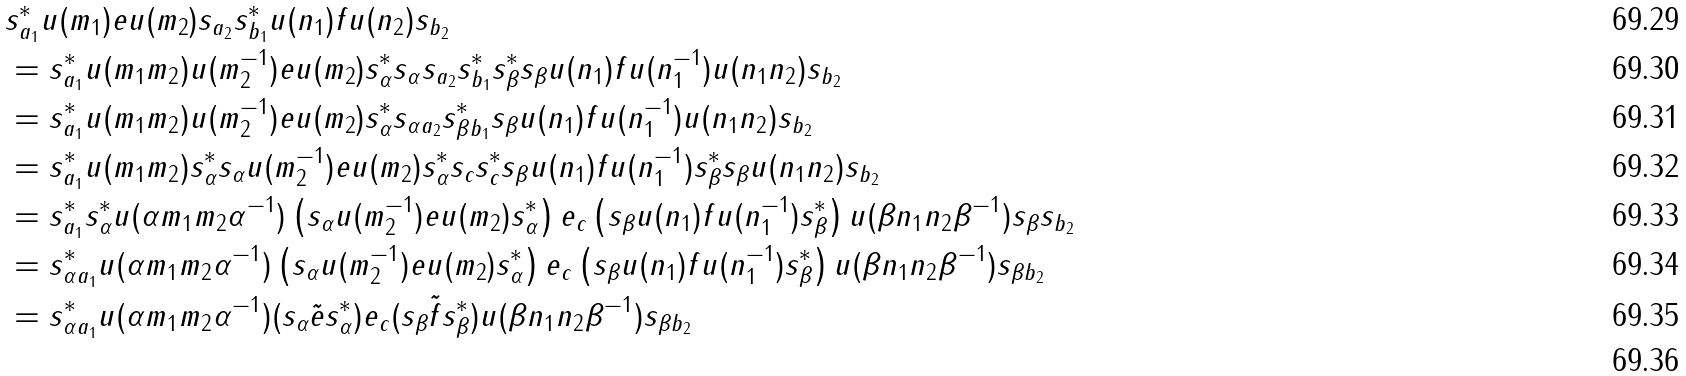<formula> <loc_0><loc_0><loc_500><loc_500>& s _ { a _ { 1 } } ^ { * } u ( m _ { 1 } ) e u ( m _ { 2 } ) s _ { a _ { 2 } } s _ { b _ { 1 } } ^ { * } u ( n _ { 1 } ) f u ( n _ { 2 } ) s _ { b _ { 2 } } \\ & = s _ { a _ { 1 } } ^ { * } u ( m _ { 1 } m _ { 2 } ) u ( m _ { 2 } ^ { - 1 } ) e u ( m _ { 2 } ) s _ { \alpha } ^ { * } s _ { \alpha } s _ { a _ { 2 } } s _ { b _ { 1 } } ^ { * } s _ { \beta } ^ { * } s _ { \beta } u ( n _ { 1 } ) f u ( n _ { 1 } ^ { - 1 } ) u ( n _ { 1 } n _ { 2 } ) s _ { b _ { 2 } } \\ & = s _ { a _ { 1 } } ^ { * } u ( m _ { 1 } m _ { 2 } ) u ( m _ { 2 } ^ { - 1 } ) e u ( m _ { 2 } ) s _ { \alpha } ^ { * } s _ { \alpha a _ { 2 } } s _ { \beta b _ { 1 } } ^ { * } s _ { \beta } u ( n _ { 1 } ) f u ( n _ { 1 } ^ { - 1 } ) u ( n _ { 1 } n _ { 2 } ) s _ { b _ { 2 } } \\ & = s _ { a _ { 1 } } ^ { * } u ( m _ { 1 } m _ { 2 } ) s _ { \alpha } ^ { * } s _ { \alpha } u ( m _ { 2 } ^ { - 1 } ) e u ( m _ { 2 } ) s _ { \alpha } ^ { * } s _ { c } s _ { c } ^ { * } s _ { \beta } u ( n _ { 1 } ) f u ( n _ { 1 } ^ { - 1 } ) s _ { \beta } ^ { * } s _ { \beta } u ( n _ { 1 } n _ { 2 } ) s _ { b _ { 2 } } \\ & = s _ { a _ { 1 } } ^ { * } s _ { \alpha } ^ { * } u ( \alpha m _ { 1 } m _ { 2 } \alpha ^ { - 1 } ) \left ( s _ { \alpha } u ( m _ { 2 } ^ { - 1 } ) e u ( m _ { 2 } ) s _ { \alpha } ^ { * } \right ) e _ { c } \left ( s _ { \beta } u ( n _ { 1 } ) f u ( n _ { 1 } ^ { - 1 } ) s _ { \beta } ^ { * } \right ) u ( \beta n _ { 1 } n _ { 2 } \beta ^ { - 1 } ) s _ { \beta } s _ { b _ { 2 } } \\ & = s _ { \alpha a _ { 1 } } ^ { * } u ( \alpha m _ { 1 } m _ { 2 } \alpha ^ { - 1 } ) \left ( s _ { \alpha } u ( m _ { 2 } ^ { - 1 } ) e u ( m _ { 2 } ) s _ { \alpha } ^ { * } \right ) e _ { c } \left ( s _ { \beta } u ( n _ { 1 } ) f u ( n _ { 1 } ^ { - 1 } ) s _ { \beta } ^ { * } \right ) u ( \beta n _ { 1 } n _ { 2 } \beta ^ { - 1 } ) s _ { \beta b _ { 2 } } \\ & = s _ { \alpha a _ { 1 } } ^ { * } u ( \alpha m _ { 1 } m _ { 2 } \alpha ^ { - 1 } ) ( s _ { \alpha } \tilde { e } s _ { \alpha } ^ { * } ) e _ { c } ( s _ { \beta } \tilde { f } s _ { \beta } ^ { * } ) u ( \beta n _ { 1 } n _ { 2 } \beta ^ { - 1 } ) s _ { \beta b _ { 2 } } \\</formula> 